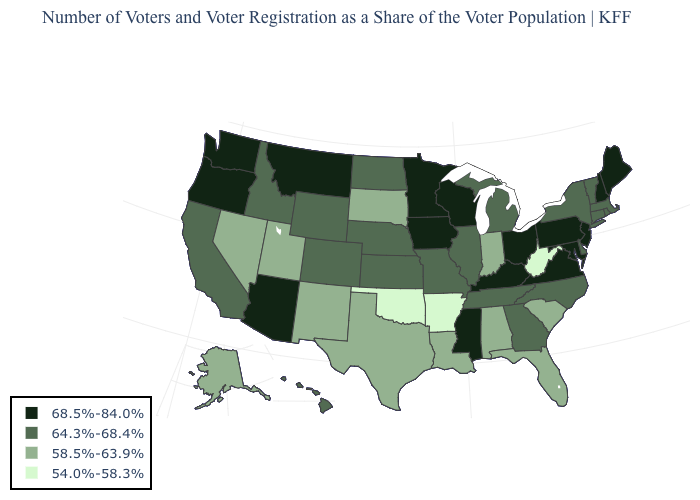Among the states that border Delaware , which have the lowest value?
Write a very short answer. Maryland, New Jersey, Pennsylvania. What is the value of Alabama?
Be succinct. 58.5%-63.9%. Name the states that have a value in the range 58.5%-63.9%?
Be succinct. Alabama, Alaska, Florida, Indiana, Louisiana, Nevada, New Mexico, South Carolina, South Dakota, Texas, Utah. Does Idaho have the lowest value in the West?
Short answer required. No. Name the states that have a value in the range 58.5%-63.9%?
Keep it brief. Alabama, Alaska, Florida, Indiana, Louisiana, Nevada, New Mexico, South Carolina, South Dakota, Texas, Utah. Does the first symbol in the legend represent the smallest category?
Short answer required. No. Does Colorado have the lowest value in the USA?
Give a very brief answer. No. What is the lowest value in the USA?
Quick response, please. 54.0%-58.3%. What is the value of Maine?
Be succinct. 68.5%-84.0%. Does Alaska have the highest value in the West?
Keep it brief. No. Is the legend a continuous bar?
Write a very short answer. No. Which states have the lowest value in the USA?
Write a very short answer. Arkansas, Oklahoma, West Virginia. Does Oklahoma have the lowest value in the South?
Write a very short answer. Yes. What is the highest value in the South ?
Concise answer only. 68.5%-84.0%. Is the legend a continuous bar?
Quick response, please. No. 